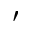Convert formula to latex. <formula><loc_0><loc_0><loc_500><loc_500>^ { \prime }</formula> 